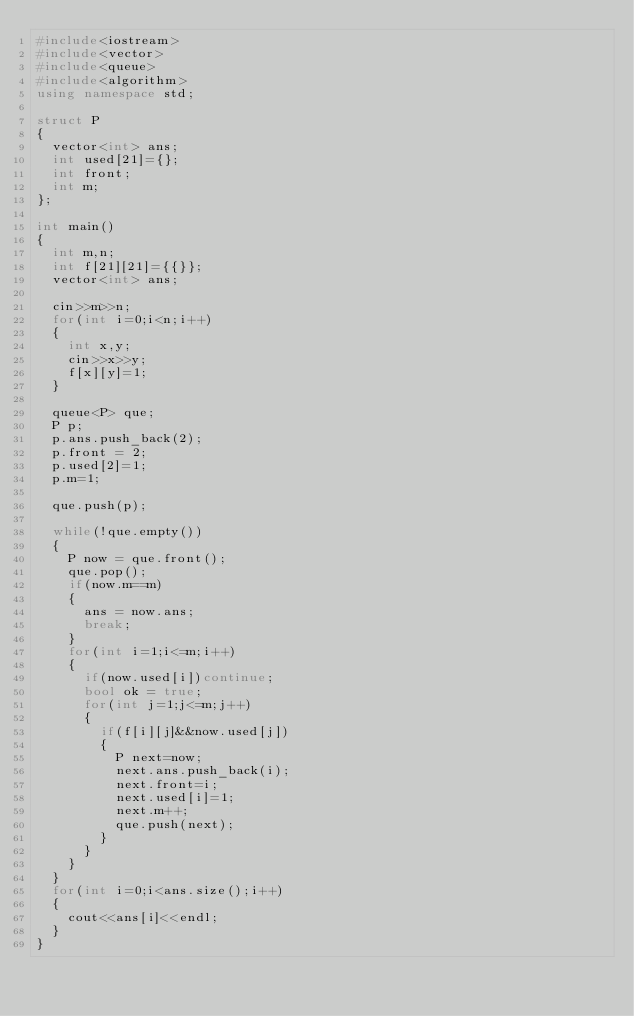<code> <loc_0><loc_0><loc_500><loc_500><_C++_>#include<iostream>
#include<vector>
#include<queue>
#include<algorithm>
using namespace std;

struct P
{
	vector<int> ans;
	int used[21]={};
	int front;
	int m;
};

int main()
{
	int m,n;
	int f[21][21]={{}};
	vector<int> ans;
	
	cin>>m>>n;
	for(int i=0;i<n;i++)
	{
		int x,y;
		cin>>x>>y;
		f[x][y]=1;
	}
	
	queue<P> que;
	P p;
	p.ans.push_back(2);
	p.front = 2;
	p.used[2]=1;
	p.m=1;
	
	que.push(p);
	
	while(!que.empty())
	{
		P now = que.front();
		que.pop();
		if(now.m==m)
		{
			ans = now.ans;
			break;
		}
		for(int i=1;i<=m;i++)
		{
			if(now.used[i])continue;
			bool ok = true;
			for(int j=1;j<=m;j++)
			{
				if(f[i][j]&&now.used[j])
				{
					P next=now;
					next.ans.push_back(i);
					next.front=i;
					next.used[i]=1;
					next.m++;
					que.push(next);
				}
			}
		}
	}
	for(int i=0;i<ans.size();i++)
	{
		cout<<ans[i]<<endl;
	}
}</code> 